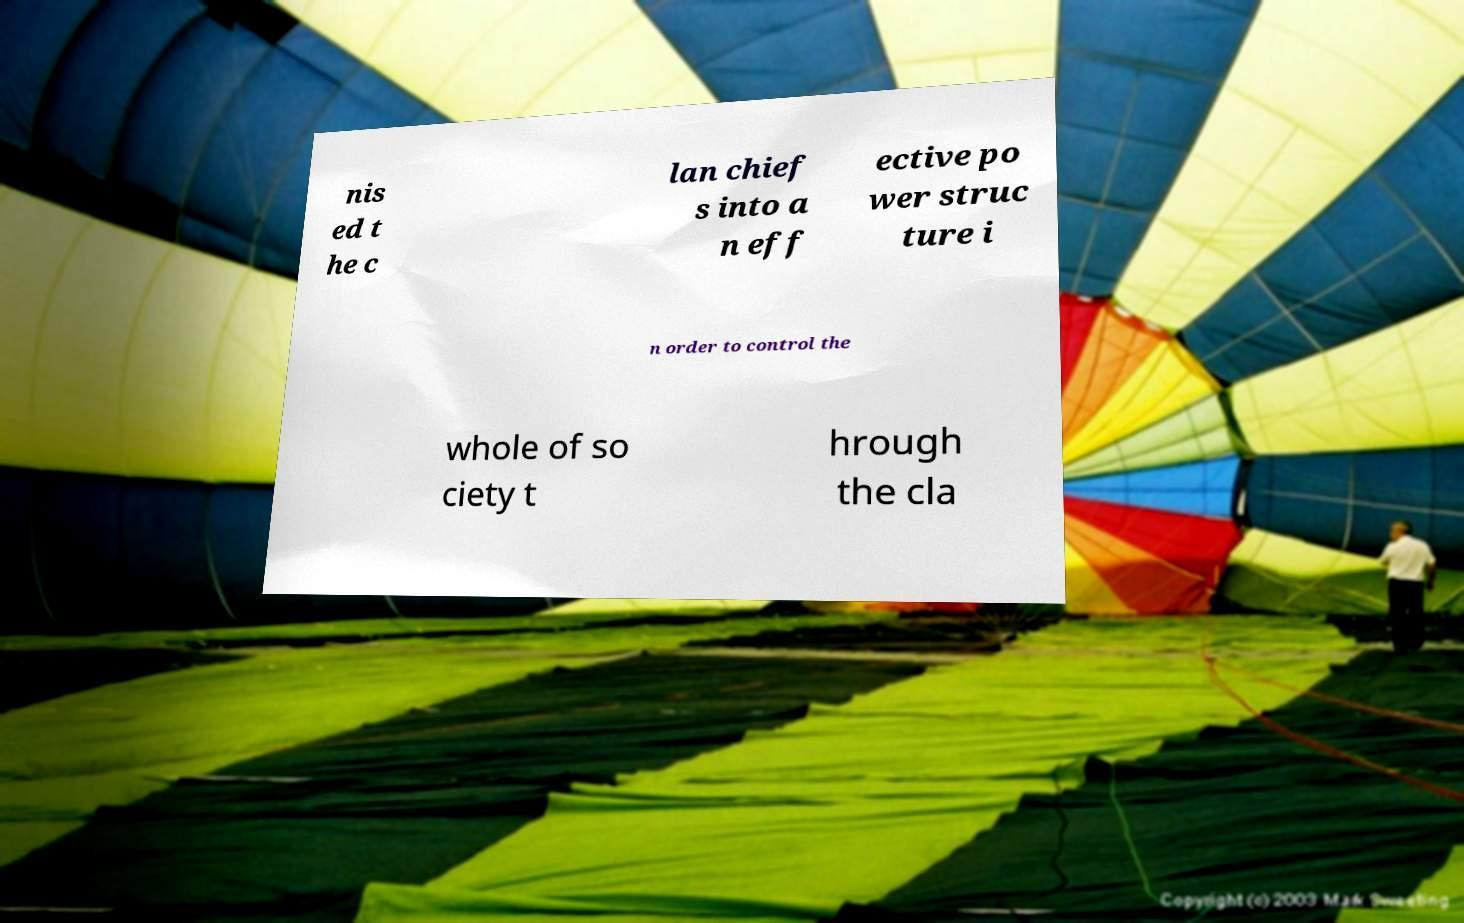For documentation purposes, I need the text within this image transcribed. Could you provide that? nis ed t he c lan chief s into a n eff ective po wer struc ture i n order to control the whole of so ciety t hrough the cla 